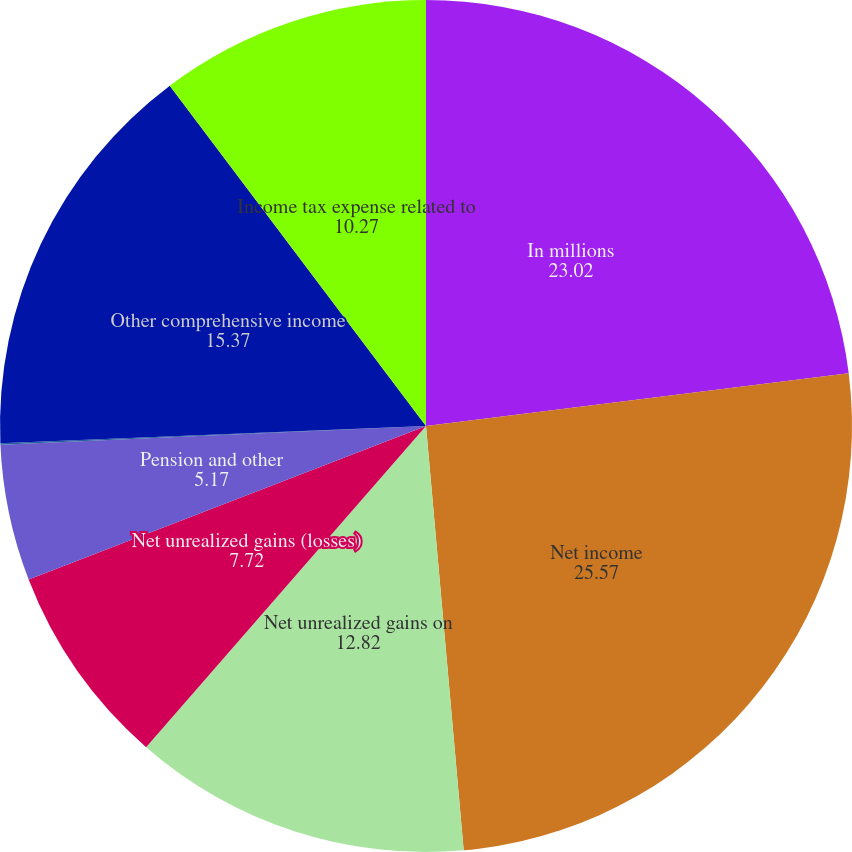Convert chart. <chart><loc_0><loc_0><loc_500><loc_500><pie_chart><fcel>In millions<fcel>Net income<fcel>Net unrealized gains on<fcel>Net unrealized gains (losses)<fcel>Pension and other<fcel>Other<fcel>Other comprehensive income<fcel>Income tax expense related to<nl><fcel>23.02%<fcel>25.57%<fcel>12.82%<fcel>7.72%<fcel>5.17%<fcel>0.06%<fcel>15.37%<fcel>10.27%<nl></chart> 